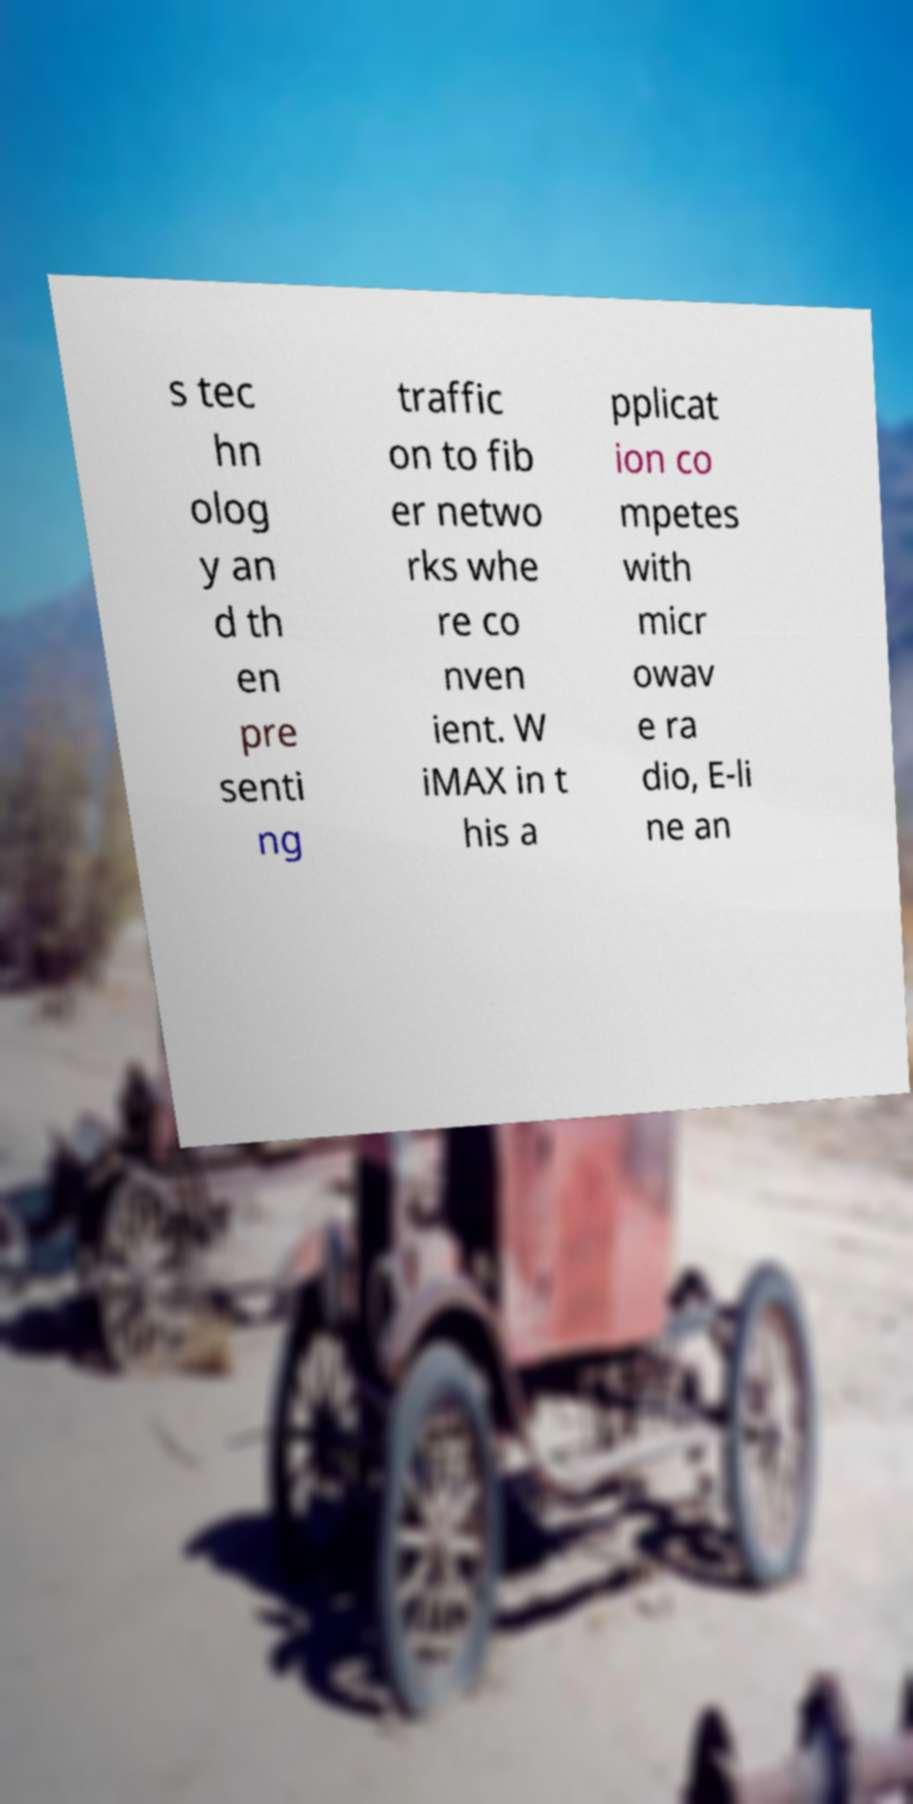Could you assist in decoding the text presented in this image and type it out clearly? s tec hn olog y an d th en pre senti ng traffic on to fib er netwo rks whe re co nven ient. W iMAX in t his a pplicat ion co mpetes with micr owav e ra dio, E-li ne an 